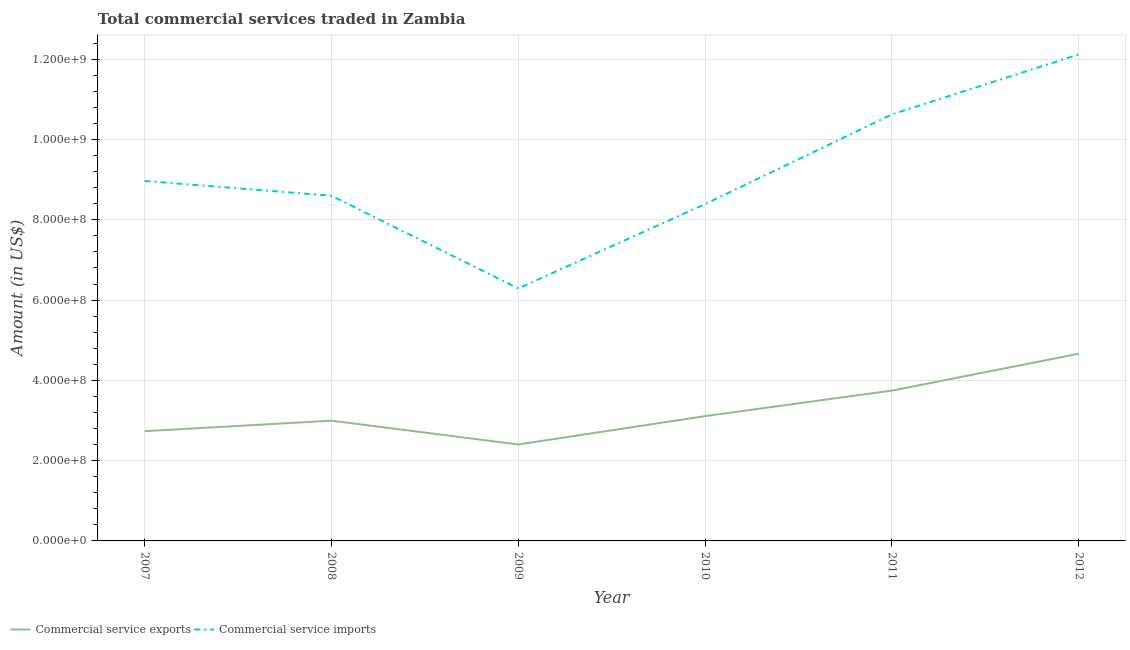How many different coloured lines are there?
Your answer should be compact. 2. Is the number of lines equal to the number of legend labels?
Your answer should be very brief. Yes. What is the amount of commercial service exports in 2011?
Your answer should be very brief. 3.75e+08. Across all years, what is the maximum amount of commercial service imports?
Your response must be concise. 1.21e+09. Across all years, what is the minimum amount of commercial service imports?
Your answer should be very brief. 6.29e+08. In which year was the amount of commercial service exports minimum?
Keep it short and to the point. 2009. What is the total amount of commercial service imports in the graph?
Keep it short and to the point. 5.50e+09. What is the difference between the amount of commercial service exports in 2010 and that in 2012?
Make the answer very short. -1.55e+08. What is the difference between the amount of commercial service exports in 2010 and the amount of commercial service imports in 2007?
Keep it short and to the point. -5.86e+08. What is the average amount of commercial service exports per year?
Make the answer very short. 3.27e+08. In the year 2011, what is the difference between the amount of commercial service imports and amount of commercial service exports?
Offer a terse response. 6.88e+08. In how many years, is the amount of commercial service imports greater than 1120000000 US$?
Your response must be concise. 1. What is the ratio of the amount of commercial service imports in 2009 to that in 2011?
Ensure brevity in your answer.  0.59. What is the difference between the highest and the second highest amount of commercial service exports?
Your answer should be very brief. 9.18e+07. What is the difference between the highest and the lowest amount of commercial service imports?
Ensure brevity in your answer.  5.83e+08. Is the sum of the amount of commercial service exports in 2011 and 2012 greater than the maximum amount of commercial service imports across all years?
Make the answer very short. No. Does the amount of commercial service exports monotonically increase over the years?
Your answer should be very brief. No. Is the amount of commercial service exports strictly greater than the amount of commercial service imports over the years?
Your response must be concise. No. What is the difference between two consecutive major ticks on the Y-axis?
Provide a short and direct response. 2.00e+08. Are the values on the major ticks of Y-axis written in scientific E-notation?
Make the answer very short. Yes. Does the graph contain grids?
Provide a succinct answer. Yes. What is the title of the graph?
Your answer should be very brief. Total commercial services traded in Zambia. Does "Secondary education" appear as one of the legend labels in the graph?
Offer a very short reply. No. What is the label or title of the X-axis?
Your response must be concise. Year. What is the label or title of the Y-axis?
Provide a succinct answer. Amount (in US$). What is the Amount (in US$) of Commercial service exports in 2007?
Make the answer very short. 2.73e+08. What is the Amount (in US$) in Commercial service imports in 2007?
Your answer should be very brief. 8.97e+08. What is the Amount (in US$) of Commercial service exports in 2008?
Your response must be concise. 3.00e+08. What is the Amount (in US$) of Commercial service imports in 2008?
Offer a terse response. 8.60e+08. What is the Amount (in US$) of Commercial service exports in 2009?
Give a very brief answer. 2.40e+08. What is the Amount (in US$) in Commercial service imports in 2009?
Your response must be concise. 6.29e+08. What is the Amount (in US$) in Commercial service exports in 2010?
Your answer should be very brief. 3.11e+08. What is the Amount (in US$) in Commercial service imports in 2010?
Keep it short and to the point. 8.39e+08. What is the Amount (in US$) of Commercial service exports in 2011?
Offer a very short reply. 3.75e+08. What is the Amount (in US$) of Commercial service imports in 2011?
Keep it short and to the point. 1.06e+09. What is the Amount (in US$) of Commercial service exports in 2012?
Keep it short and to the point. 4.66e+08. What is the Amount (in US$) in Commercial service imports in 2012?
Give a very brief answer. 1.21e+09. Across all years, what is the maximum Amount (in US$) of Commercial service exports?
Provide a succinct answer. 4.66e+08. Across all years, what is the maximum Amount (in US$) of Commercial service imports?
Give a very brief answer. 1.21e+09. Across all years, what is the minimum Amount (in US$) of Commercial service exports?
Offer a terse response. 2.40e+08. Across all years, what is the minimum Amount (in US$) in Commercial service imports?
Provide a succinct answer. 6.29e+08. What is the total Amount (in US$) of Commercial service exports in the graph?
Provide a succinct answer. 1.96e+09. What is the total Amount (in US$) of Commercial service imports in the graph?
Ensure brevity in your answer.  5.50e+09. What is the difference between the Amount (in US$) of Commercial service exports in 2007 and that in 2008?
Provide a succinct answer. -2.62e+07. What is the difference between the Amount (in US$) of Commercial service imports in 2007 and that in 2008?
Offer a very short reply. 3.68e+07. What is the difference between the Amount (in US$) in Commercial service exports in 2007 and that in 2009?
Your answer should be compact. 3.31e+07. What is the difference between the Amount (in US$) of Commercial service imports in 2007 and that in 2009?
Offer a very short reply. 2.68e+08. What is the difference between the Amount (in US$) of Commercial service exports in 2007 and that in 2010?
Make the answer very short. -3.75e+07. What is the difference between the Amount (in US$) of Commercial service imports in 2007 and that in 2010?
Your answer should be very brief. 5.76e+07. What is the difference between the Amount (in US$) in Commercial service exports in 2007 and that in 2011?
Provide a succinct answer. -1.01e+08. What is the difference between the Amount (in US$) in Commercial service imports in 2007 and that in 2011?
Provide a succinct answer. -1.66e+08. What is the difference between the Amount (in US$) in Commercial service exports in 2007 and that in 2012?
Offer a terse response. -1.93e+08. What is the difference between the Amount (in US$) in Commercial service imports in 2007 and that in 2012?
Keep it short and to the point. -3.15e+08. What is the difference between the Amount (in US$) of Commercial service exports in 2008 and that in 2009?
Ensure brevity in your answer.  5.93e+07. What is the difference between the Amount (in US$) in Commercial service imports in 2008 and that in 2009?
Make the answer very short. 2.31e+08. What is the difference between the Amount (in US$) of Commercial service exports in 2008 and that in 2010?
Make the answer very short. -1.14e+07. What is the difference between the Amount (in US$) of Commercial service imports in 2008 and that in 2010?
Your answer should be compact. 2.08e+07. What is the difference between the Amount (in US$) of Commercial service exports in 2008 and that in 2011?
Your answer should be compact. -7.49e+07. What is the difference between the Amount (in US$) of Commercial service imports in 2008 and that in 2011?
Make the answer very short. -2.03e+08. What is the difference between the Amount (in US$) in Commercial service exports in 2008 and that in 2012?
Offer a terse response. -1.67e+08. What is the difference between the Amount (in US$) in Commercial service imports in 2008 and that in 2012?
Your response must be concise. -3.52e+08. What is the difference between the Amount (in US$) of Commercial service exports in 2009 and that in 2010?
Ensure brevity in your answer.  -7.07e+07. What is the difference between the Amount (in US$) of Commercial service imports in 2009 and that in 2010?
Provide a short and direct response. -2.10e+08. What is the difference between the Amount (in US$) of Commercial service exports in 2009 and that in 2011?
Provide a succinct answer. -1.34e+08. What is the difference between the Amount (in US$) of Commercial service imports in 2009 and that in 2011?
Give a very brief answer. -4.34e+08. What is the difference between the Amount (in US$) in Commercial service exports in 2009 and that in 2012?
Ensure brevity in your answer.  -2.26e+08. What is the difference between the Amount (in US$) in Commercial service imports in 2009 and that in 2012?
Keep it short and to the point. -5.83e+08. What is the difference between the Amount (in US$) in Commercial service exports in 2010 and that in 2011?
Offer a very short reply. -6.36e+07. What is the difference between the Amount (in US$) in Commercial service imports in 2010 and that in 2011?
Make the answer very short. -2.23e+08. What is the difference between the Amount (in US$) of Commercial service exports in 2010 and that in 2012?
Offer a terse response. -1.55e+08. What is the difference between the Amount (in US$) in Commercial service imports in 2010 and that in 2012?
Offer a very short reply. -3.73e+08. What is the difference between the Amount (in US$) of Commercial service exports in 2011 and that in 2012?
Make the answer very short. -9.18e+07. What is the difference between the Amount (in US$) in Commercial service imports in 2011 and that in 2012?
Give a very brief answer. -1.49e+08. What is the difference between the Amount (in US$) of Commercial service exports in 2007 and the Amount (in US$) of Commercial service imports in 2008?
Your response must be concise. -5.87e+08. What is the difference between the Amount (in US$) in Commercial service exports in 2007 and the Amount (in US$) in Commercial service imports in 2009?
Give a very brief answer. -3.56e+08. What is the difference between the Amount (in US$) in Commercial service exports in 2007 and the Amount (in US$) in Commercial service imports in 2010?
Offer a terse response. -5.66e+08. What is the difference between the Amount (in US$) of Commercial service exports in 2007 and the Amount (in US$) of Commercial service imports in 2011?
Give a very brief answer. -7.89e+08. What is the difference between the Amount (in US$) in Commercial service exports in 2007 and the Amount (in US$) in Commercial service imports in 2012?
Your answer should be very brief. -9.39e+08. What is the difference between the Amount (in US$) in Commercial service exports in 2008 and the Amount (in US$) in Commercial service imports in 2009?
Provide a short and direct response. -3.29e+08. What is the difference between the Amount (in US$) of Commercial service exports in 2008 and the Amount (in US$) of Commercial service imports in 2010?
Provide a succinct answer. -5.40e+08. What is the difference between the Amount (in US$) in Commercial service exports in 2008 and the Amount (in US$) in Commercial service imports in 2011?
Provide a short and direct response. -7.63e+08. What is the difference between the Amount (in US$) of Commercial service exports in 2008 and the Amount (in US$) of Commercial service imports in 2012?
Your response must be concise. -9.13e+08. What is the difference between the Amount (in US$) of Commercial service exports in 2009 and the Amount (in US$) of Commercial service imports in 2010?
Provide a short and direct response. -5.99e+08. What is the difference between the Amount (in US$) in Commercial service exports in 2009 and the Amount (in US$) in Commercial service imports in 2011?
Your answer should be very brief. -8.22e+08. What is the difference between the Amount (in US$) in Commercial service exports in 2009 and the Amount (in US$) in Commercial service imports in 2012?
Your answer should be very brief. -9.72e+08. What is the difference between the Amount (in US$) of Commercial service exports in 2010 and the Amount (in US$) of Commercial service imports in 2011?
Provide a short and direct response. -7.52e+08. What is the difference between the Amount (in US$) of Commercial service exports in 2010 and the Amount (in US$) of Commercial service imports in 2012?
Provide a short and direct response. -9.01e+08. What is the difference between the Amount (in US$) of Commercial service exports in 2011 and the Amount (in US$) of Commercial service imports in 2012?
Offer a very short reply. -8.38e+08. What is the average Amount (in US$) of Commercial service exports per year?
Offer a very short reply. 3.27e+08. What is the average Amount (in US$) of Commercial service imports per year?
Your answer should be compact. 9.17e+08. In the year 2007, what is the difference between the Amount (in US$) of Commercial service exports and Amount (in US$) of Commercial service imports?
Your response must be concise. -6.23e+08. In the year 2008, what is the difference between the Amount (in US$) in Commercial service exports and Amount (in US$) in Commercial service imports?
Your response must be concise. -5.60e+08. In the year 2009, what is the difference between the Amount (in US$) of Commercial service exports and Amount (in US$) of Commercial service imports?
Offer a terse response. -3.89e+08. In the year 2010, what is the difference between the Amount (in US$) of Commercial service exports and Amount (in US$) of Commercial service imports?
Offer a very short reply. -5.28e+08. In the year 2011, what is the difference between the Amount (in US$) of Commercial service exports and Amount (in US$) of Commercial service imports?
Make the answer very short. -6.88e+08. In the year 2012, what is the difference between the Amount (in US$) in Commercial service exports and Amount (in US$) in Commercial service imports?
Give a very brief answer. -7.46e+08. What is the ratio of the Amount (in US$) in Commercial service exports in 2007 to that in 2008?
Provide a short and direct response. 0.91. What is the ratio of the Amount (in US$) of Commercial service imports in 2007 to that in 2008?
Offer a terse response. 1.04. What is the ratio of the Amount (in US$) in Commercial service exports in 2007 to that in 2009?
Give a very brief answer. 1.14. What is the ratio of the Amount (in US$) in Commercial service imports in 2007 to that in 2009?
Keep it short and to the point. 1.43. What is the ratio of the Amount (in US$) of Commercial service exports in 2007 to that in 2010?
Your answer should be compact. 0.88. What is the ratio of the Amount (in US$) of Commercial service imports in 2007 to that in 2010?
Offer a terse response. 1.07. What is the ratio of the Amount (in US$) in Commercial service exports in 2007 to that in 2011?
Offer a terse response. 0.73. What is the ratio of the Amount (in US$) of Commercial service imports in 2007 to that in 2011?
Offer a terse response. 0.84. What is the ratio of the Amount (in US$) of Commercial service exports in 2007 to that in 2012?
Provide a short and direct response. 0.59. What is the ratio of the Amount (in US$) in Commercial service imports in 2007 to that in 2012?
Your response must be concise. 0.74. What is the ratio of the Amount (in US$) of Commercial service exports in 2008 to that in 2009?
Your answer should be very brief. 1.25. What is the ratio of the Amount (in US$) in Commercial service imports in 2008 to that in 2009?
Offer a very short reply. 1.37. What is the ratio of the Amount (in US$) of Commercial service exports in 2008 to that in 2010?
Provide a short and direct response. 0.96. What is the ratio of the Amount (in US$) of Commercial service imports in 2008 to that in 2010?
Offer a very short reply. 1.02. What is the ratio of the Amount (in US$) of Commercial service exports in 2008 to that in 2011?
Provide a short and direct response. 0.8. What is the ratio of the Amount (in US$) of Commercial service imports in 2008 to that in 2011?
Ensure brevity in your answer.  0.81. What is the ratio of the Amount (in US$) in Commercial service exports in 2008 to that in 2012?
Ensure brevity in your answer.  0.64. What is the ratio of the Amount (in US$) in Commercial service imports in 2008 to that in 2012?
Provide a succinct answer. 0.71. What is the ratio of the Amount (in US$) of Commercial service exports in 2009 to that in 2010?
Keep it short and to the point. 0.77. What is the ratio of the Amount (in US$) of Commercial service imports in 2009 to that in 2010?
Your answer should be very brief. 0.75. What is the ratio of the Amount (in US$) of Commercial service exports in 2009 to that in 2011?
Ensure brevity in your answer.  0.64. What is the ratio of the Amount (in US$) in Commercial service imports in 2009 to that in 2011?
Provide a short and direct response. 0.59. What is the ratio of the Amount (in US$) of Commercial service exports in 2009 to that in 2012?
Offer a terse response. 0.52. What is the ratio of the Amount (in US$) in Commercial service imports in 2009 to that in 2012?
Offer a very short reply. 0.52. What is the ratio of the Amount (in US$) of Commercial service exports in 2010 to that in 2011?
Your response must be concise. 0.83. What is the ratio of the Amount (in US$) in Commercial service imports in 2010 to that in 2011?
Your response must be concise. 0.79. What is the ratio of the Amount (in US$) in Commercial service exports in 2010 to that in 2012?
Give a very brief answer. 0.67. What is the ratio of the Amount (in US$) in Commercial service imports in 2010 to that in 2012?
Offer a very short reply. 0.69. What is the ratio of the Amount (in US$) in Commercial service exports in 2011 to that in 2012?
Offer a very short reply. 0.8. What is the ratio of the Amount (in US$) of Commercial service imports in 2011 to that in 2012?
Provide a succinct answer. 0.88. What is the difference between the highest and the second highest Amount (in US$) in Commercial service exports?
Your response must be concise. 9.18e+07. What is the difference between the highest and the second highest Amount (in US$) in Commercial service imports?
Offer a terse response. 1.49e+08. What is the difference between the highest and the lowest Amount (in US$) in Commercial service exports?
Give a very brief answer. 2.26e+08. What is the difference between the highest and the lowest Amount (in US$) in Commercial service imports?
Offer a terse response. 5.83e+08. 